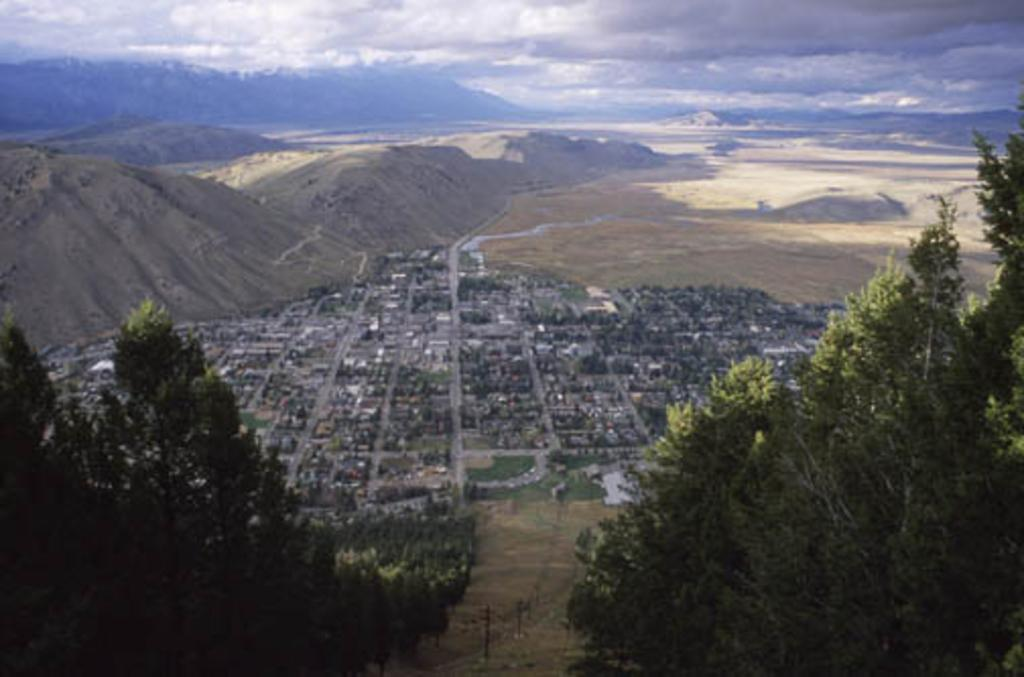What type of natural elements can be seen in the image? There are trees and mountains in the image. What type of man-made structures are present in the image? There are buildings in the image. What type of transportation infrastructure can be seen in the image? There are roads in the image. What part of the natural environment is visible in the image? The sky is visible in the image. What type of silk can be seen draped over the trees in the image? There is no silk present in the image; it features trees, buildings, roads, mountains, and the sky. What type of trouble might the basin be causing in the image? There is no basin present in the image, so it cannot be causing any trouble. 